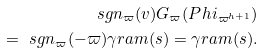<formula> <loc_0><loc_0><loc_500><loc_500>\ s g n _ { \varpi } ( v ) G _ { \varpi } ( P h i _ { \varpi ^ { h + 1 } } ) \\ = \ s g n _ { \varpi } ( - \varpi ) \gamma r a m ( s ) = \gamma r a m ( s ) .</formula> 